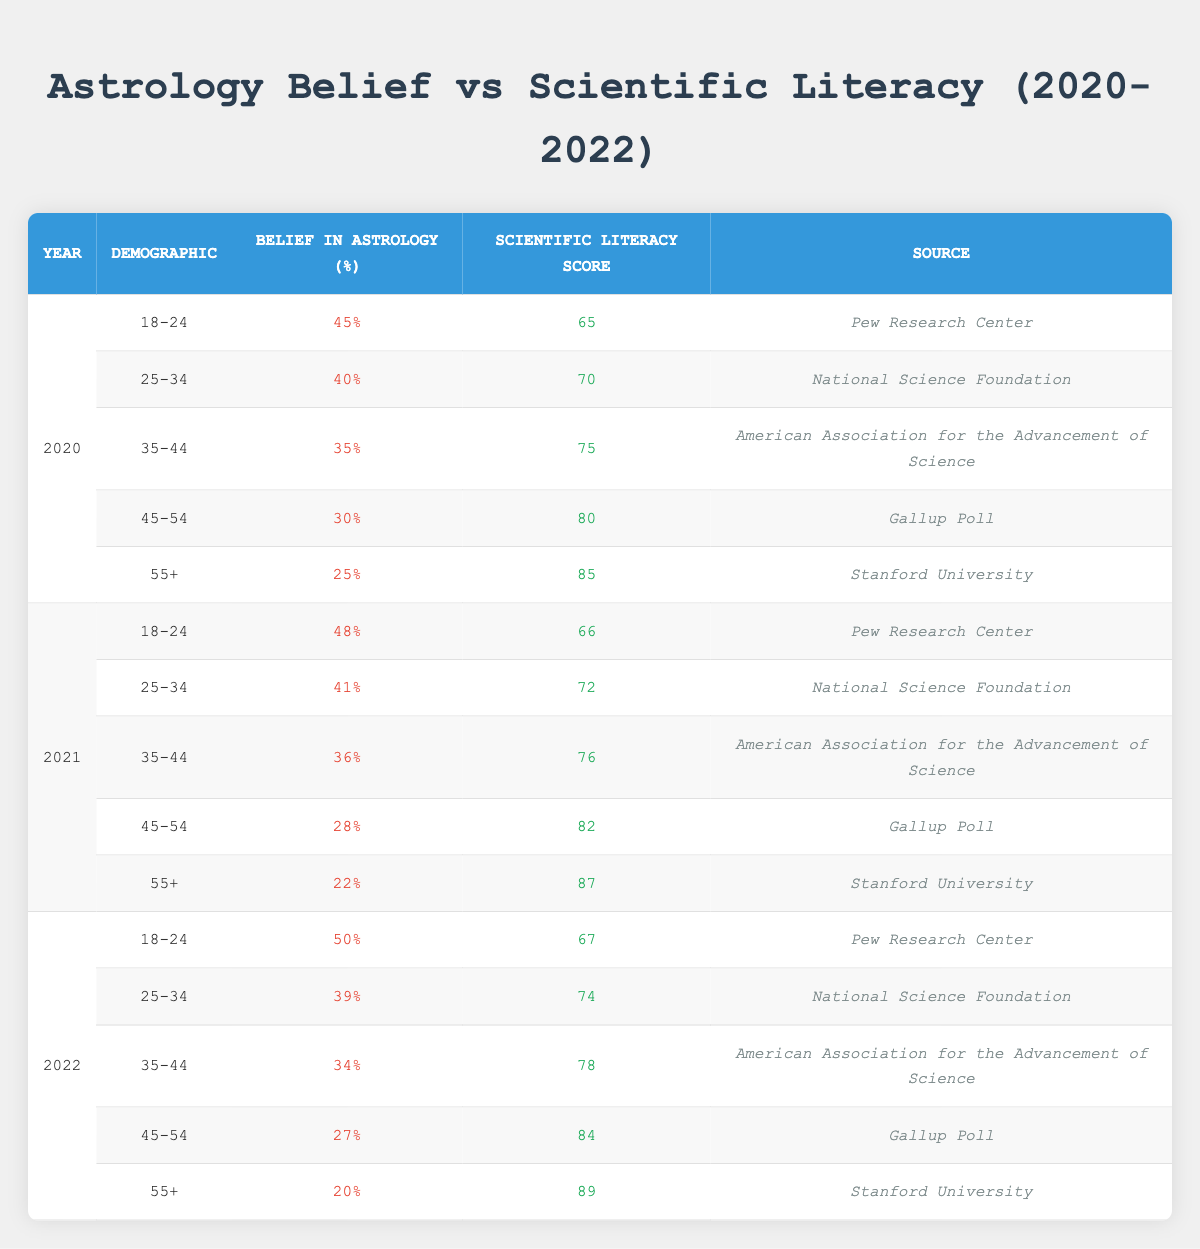What was the belief in astrology percentage for the demographic 45-54 in 2021? In the row for 2021 and the demographic 45-54, the table indicates that the belief in astrology percentage is 28%.
Answer: 28% What was the scientific literacy score for the demographic 18-24 in 2020? Looking up the demographic 18-24 for the year 2020, the scientific literacy score listed is 65.
Answer: 65 What is the difference in belief in astrology percentage between the 55+ demographic in 2020 and 2022? For the 55+ demographic, the belief in astrology percentage is 25% in 2020 and 20% in 2022. The difference is 25% - 20% = 5%.
Answer: 5% What is the average scientific literacy score for the 25-34 demographic across all three years? The scientific literacy scores for the 25-34 demographic are 70 (2020), 72 (2021), and 74 (2022). Summing these gives 70 + 72 + 74 = 216. The average is 216/3 = 72.
Answer: 72 Is the belief in astrology percentage for the demographic 35-44 increasing every year? In the years provided, the percentages for the demographic 35-44 are 35% in 2020, 36% in 2021, and 34% in 2022. This shows an increase from 2020 to 2021 and then a decrease in 2022. Therefore, it is not consistently increasing.
Answer: No Which demographic had the highest scientific literacy score in 2022? In 2022, the highest scientific literacy score is 89, which corresponds to the 55+ demographic.
Answer: 55+ What is the percentage of belief in astrology for the demographic 18-24 in 2022 compared to 2020? In 2022, the belief in astrology for the demographic 18-24 is 50%, while in 2020 it was 45%. The comparison shows an increase of 5%.
Answer: 5% increase What can we conclude about the trend in belief in astrology across the demographic groups from 2020 to 2022? Analyzing the data, every demographic group shows a slight decrease in belief in astrology from 2020 to 2022, except for the 18-24 demographic which increased. Therefore, overall, there is a declining trend in belief in astrology, with the younger group being the exception.
Answer: Decreasing trend overall, with one exception In which year did the 45-54 demographic show the greatest decrease in belief in astrology? Comparing the beliefs in astrology for the 45-54 demographic: 30% in 2020, 28% in 2021, and 27% in 2022. The greatest decrease was from 2020 to 2021, where it dropped by 2%.
Answer: 2020 to 2021 What is the median belief in astrology percentage for all demographics in 2021? For 2021, the belief percentages are: 48%, 41%, 36%, 28%, and 22%. When arranged in ascending order (22%, 28%, 36%, 41%, 48%), the median (middle value) is 36%.
Answer: 36% 